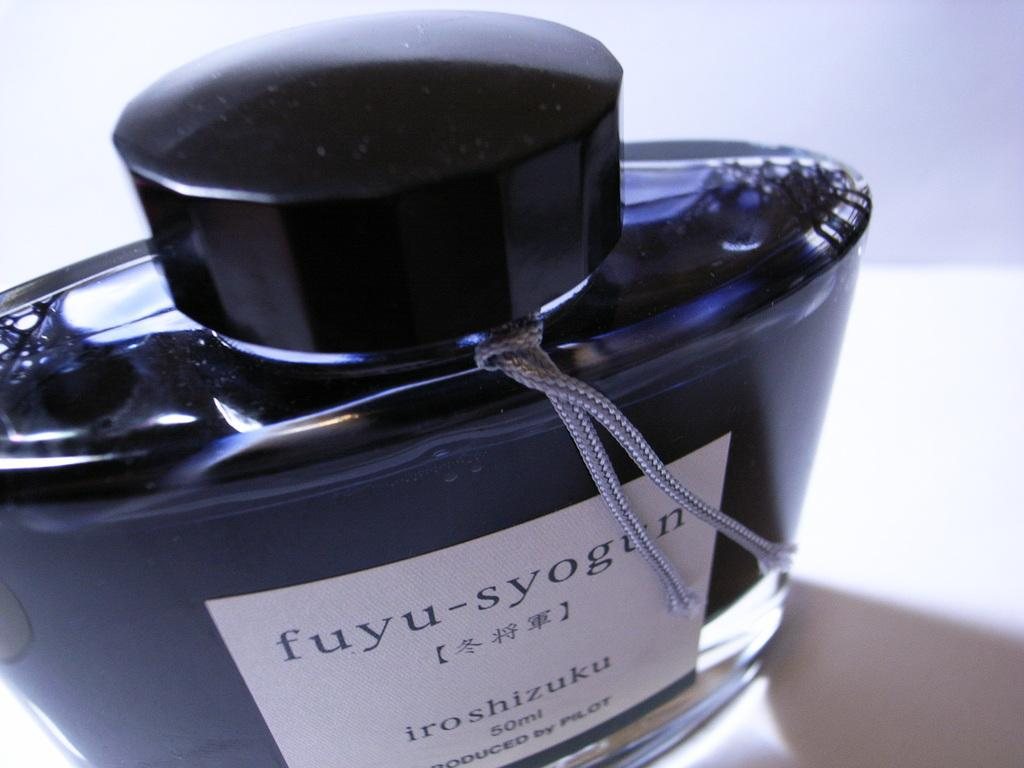<image>
Relay a brief, clear account of the picture shown. A 50mL bottle of fuyu-syogun ink was made by Pilot. 